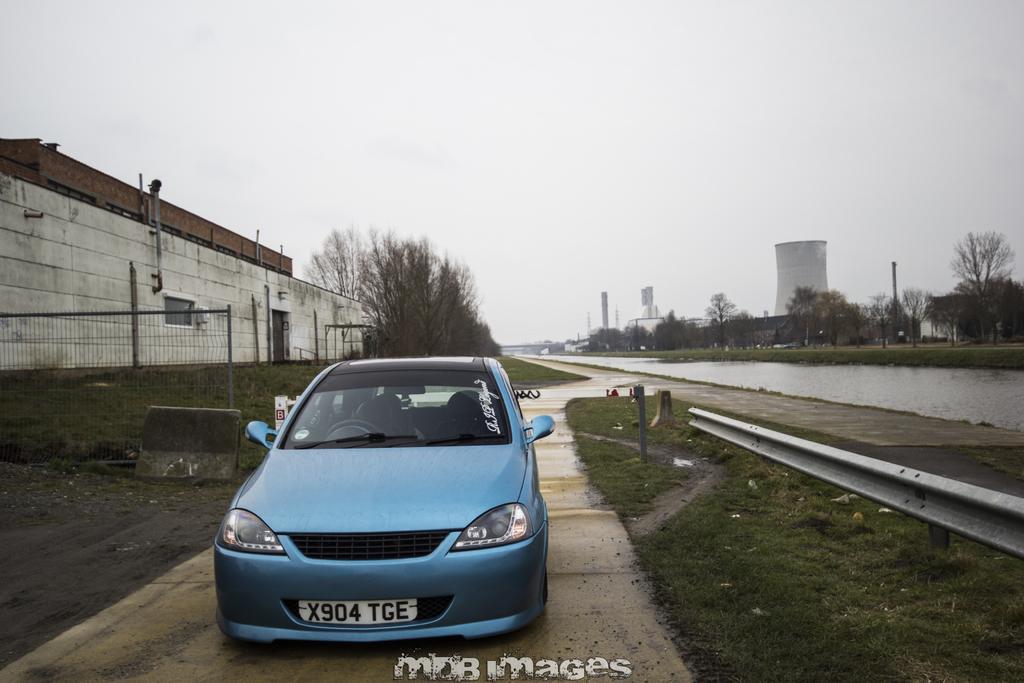How would you summarize this image in a sentence or two? In this picture I can see buildings, trees and a water canal and I can see a blue color car parked and grass on the ground and I can see a cloudy sky and text at the bottom of the picture. 